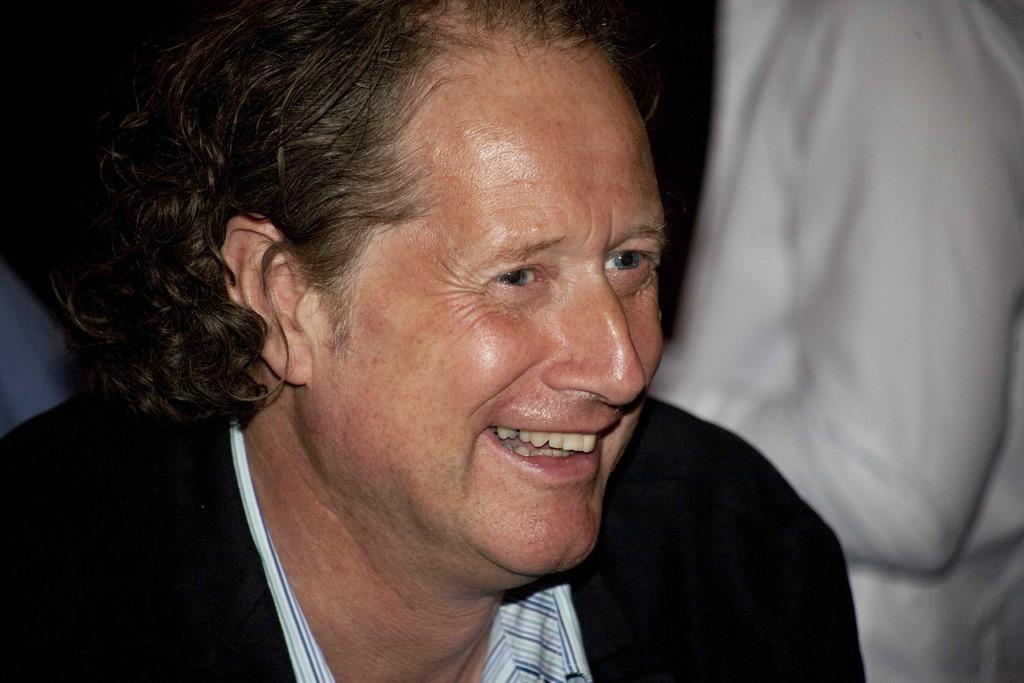What is the main subject of the image? There is a man in the image. What is the man wearing? The man is wearing a black suit. What is the man's facial expression? The man is smiling. Can you describe the background of the image? The background of the image is blurred. How many geese are visible in the image? There are no geese present in the image. What type of sticks can be seen in the man's hand? The man is not holding any sticks in the image. Is there a sink visible in the background of the image? There is no sink present in the image. 